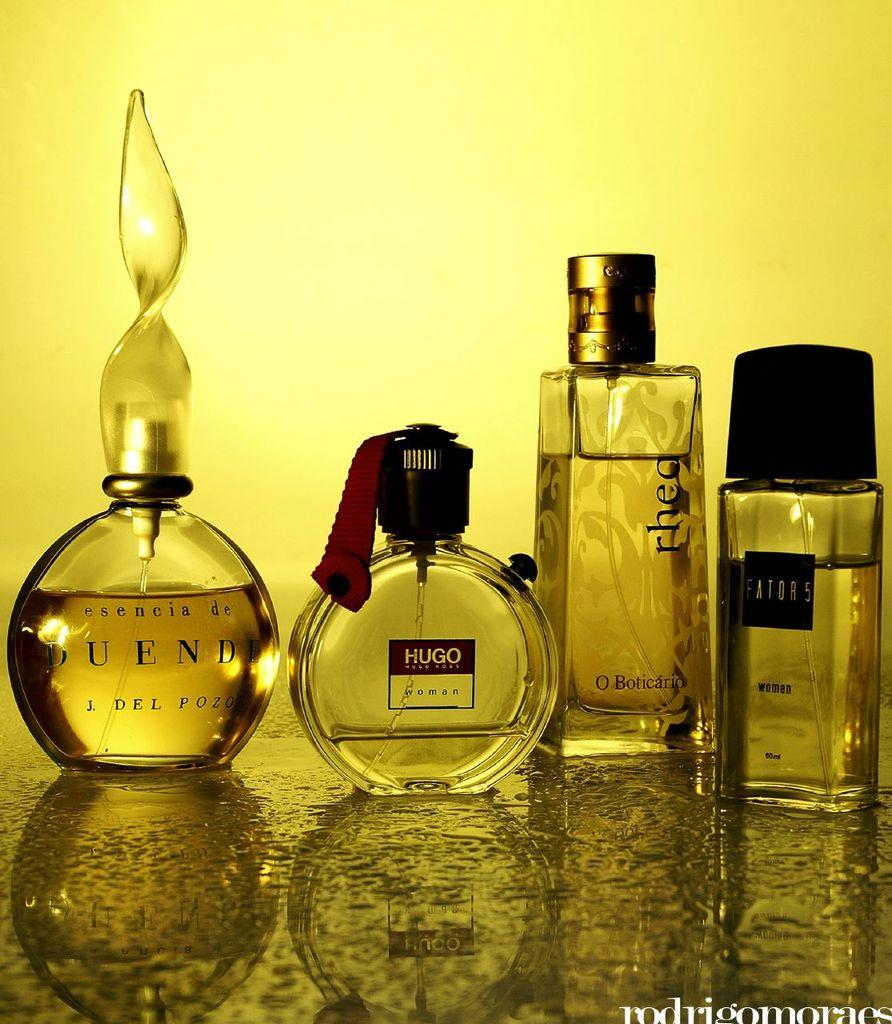<image>
Give a short and clear explanation of the subsequent image. Botthe of Duende perfume next to a bottle of Hugo. 